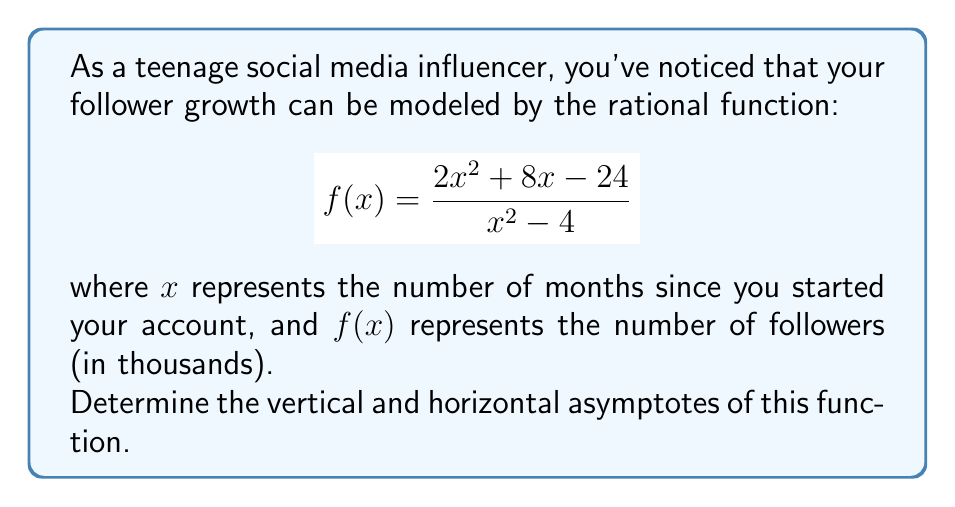Can you solve this math problem? Let's approach this step-by-step:

1. Vertical Asymptotes:
   Vertical asymptotes occur when the denominator equals zero, but the numerator doesn't.
   Set the denominator to zero:
   $$x^2 - 4 = 0$$
   $$(x+2)(x-2) = 0$$
   $$x = -2 \text{ or } x = 2$$
   
   Check if the numerator is zero for these x values:
   When $x = -2$: $2(-2)^2 + 8(-2) - 24 = 8 - 16 - 24 = -32 \neq 0$
   When $x = 2$: $2(2)^2 + 8(2) - 24 = 8 + 16 - 24 = 0$
   
   Therefore, there is only one vertical asymptote at $x = -2$.

2. Horizontal Asymptote:
   To find the horizontal asymptote, we compare the degrees of the numerator and denominator.
   Both have degree 2, so we divide the leading coefficients:
   
   $$\lim_{x \to \infty} \frac{2x^2 + 8x - 24}{x^2 - 4} = \frac{2}{1} = 2$$

   The horizontal asymptote is $y = 2$.
Answer: Vertical asymptote: $x = -2$
Horizontal asymptote: $y = 2$ 